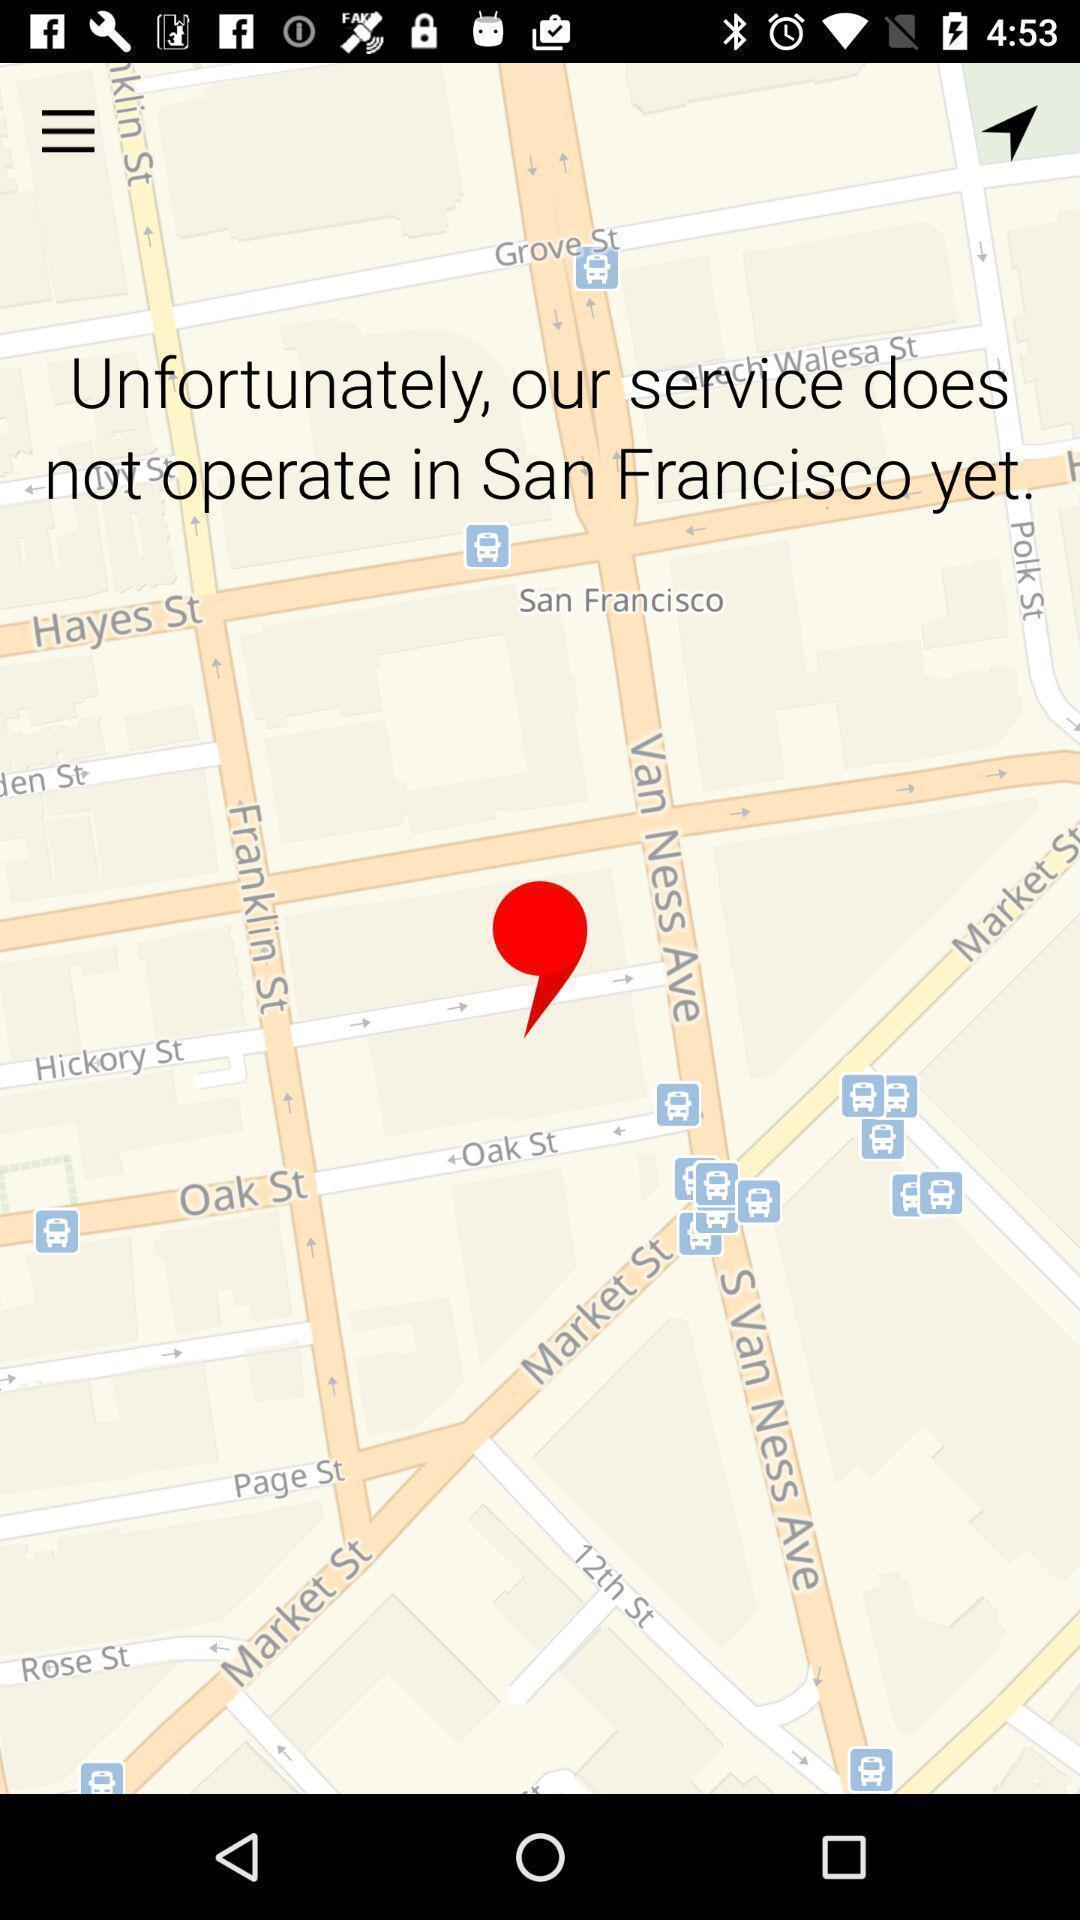Provide a detailed account of this screenshot. Page displaying with maps application with information for search. 